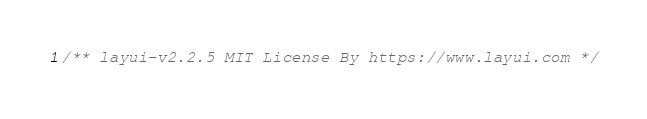<code> <loc_0><loc_0><loc_500><loc_500><_CSS_>/** layui-v2.2.5 MIT License By https://www.layui.com */</code> 